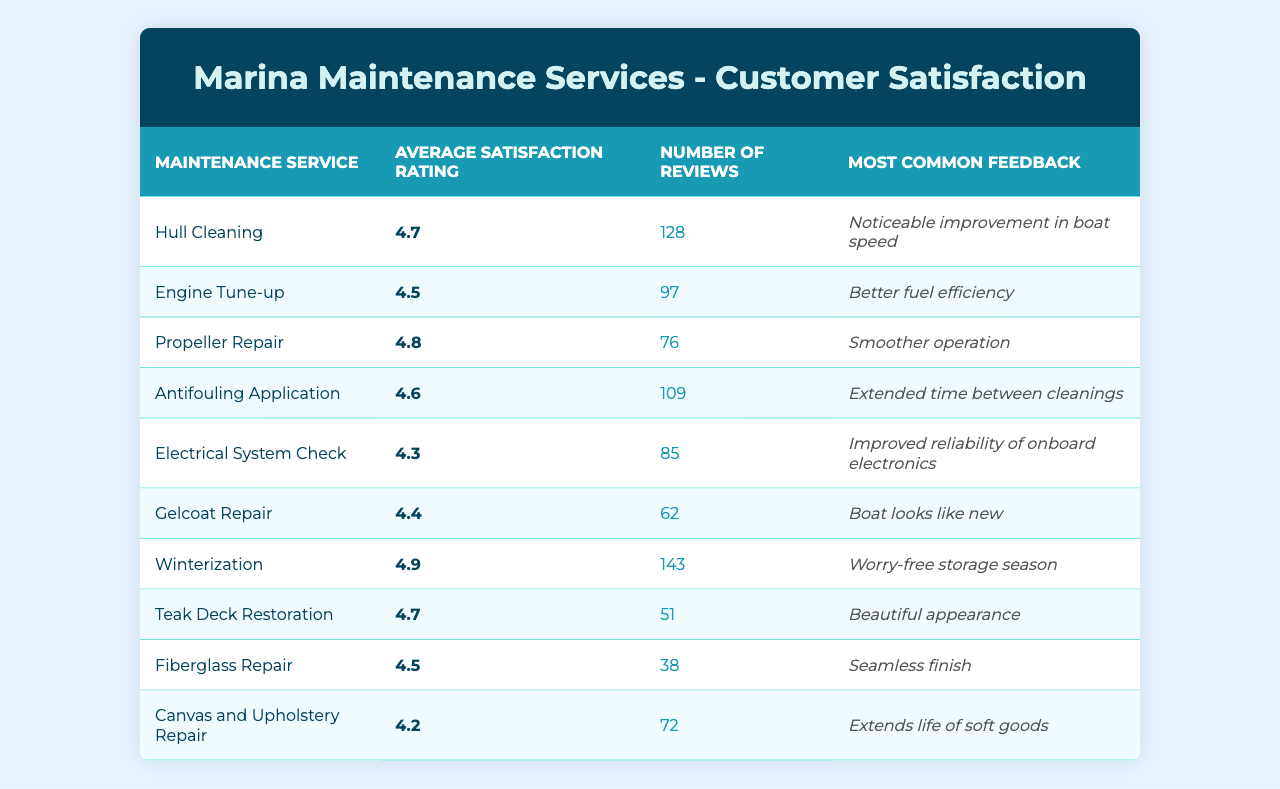What's the average satisfaction rating for the 'Hull Cleaning' service? According to the table, the 'Hull Cleaning' service has an average satisfaction rating of 4.7.
Answer: 4.7 Which maintenance service received the highest number of reviews? By comparing the 'Number of Reviews' for each service, 'Winterization' has the highest number with 143 reviews.
Answer: Winterization What is the most common feedback for 'Electrical System Check'? The table lists the most common feedback for 'Electrical System Check' as "Improved reliability of onboard electronics."
Answer: Improved reliability of onboard electronics Is the average satisfaction rating for 'Canvas and Upholstery Repair' above or below 4.5? The average satisfaction rating for 'Canvas and Upholstery Repair' is 4.2, which is below 4.5.
Answer: Below What is the difference in average satisfaction ratings between 'Propeller Repair' and 'Engine Tune-up'? 'Propeller Repair' has an average rating of 4.8, while 'Engine Tune-up' is 4.5. The difference is 4.8 - 4.5 = 0.3.
Answer: 0.3 Which maintenance service has the lowest average satisfaction rating, and what is that rating? By reviewing the average satisfaction ratings, 'Canvas and Upholstery Repair' has the lowest rating at 4.2.
Answer: Canvas and Upholstery Repair, 4.2 How many more reviews does 'Hull Cleaning' have compared to 'Gelcoat Repair'? 'Hull Cleaning' has 128 reviews and 'Gelcoat Repair' has 62. The difference is 128 - 62 = 66.
Answer: 66 If we were to calculate the average satisfaction rating of services that received more than 100 reviews, what would that be? The services with more than 100 reviews are 'Hull Cleaning' (4.7), 'Antifouling Application' (4.6), and 'Winterization' (4.9). Summing these ratings gives 4.7 + 4.6 + 4.9 = 14.2, and dividing by 3 gives an average of 14.2 / 3 = 4.73.
Answer: 4.73 Are there any services with a rating of 4.9, and if so, which one? Yes, 'Winterization' has an average satisfaction rating of 4.9.
Answer: Yes, Winterization What percentage of total reviews does 'Teak Deck Restoration' represent (rounded to the nearest whole number) compared to the total number of reviews across all services? The total number of reviews is 128 + 97 + 76 + 109 + 85 + 62 + 143 + 51 + 38 + 72 = 820. 'Teak Deck Restoration' has 51 reviews, which is (51 / 820) * 100 ≈ 6.2%. Rounding to the nearest whole number gives 6%.
Answer: 6% 